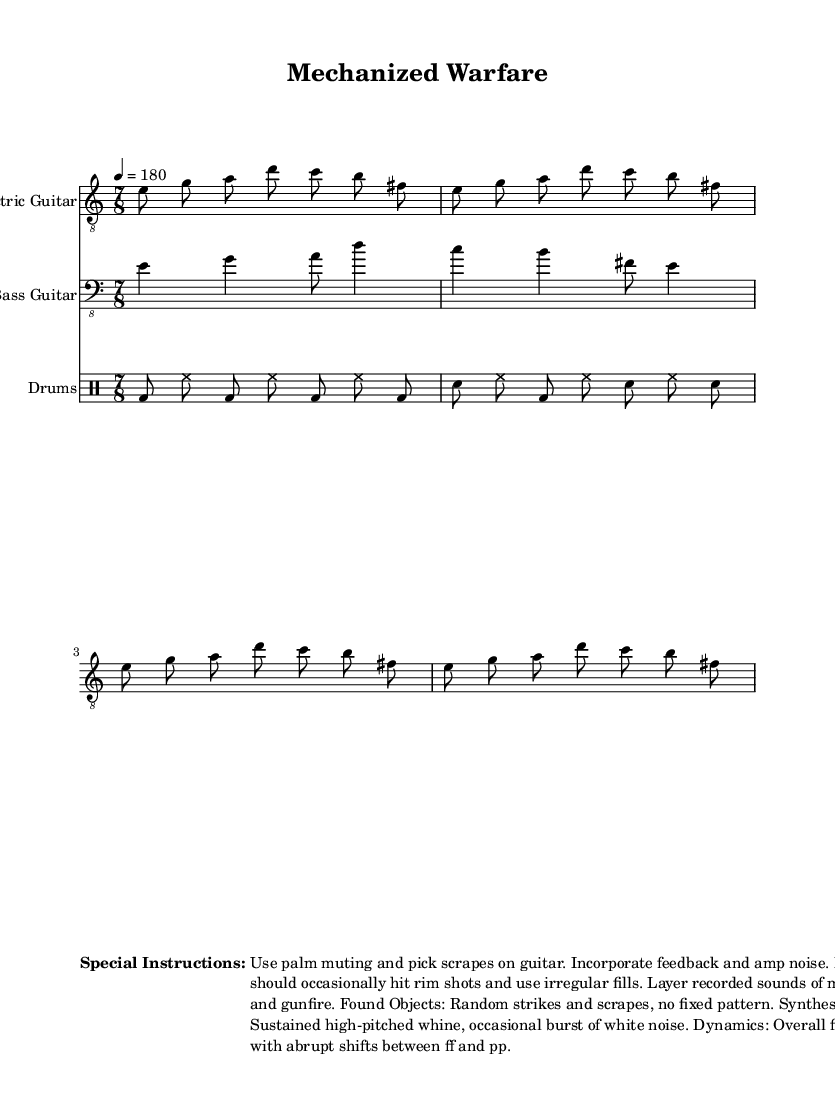what is the time signature of this music? The time signature is indicated at the beginning and shows that there are 7 beats per measure. This is represented as 7/8.
Answer: 7/8 what is the tempo marking of this piece? The tempo marking specifies that the quarter note equals 180 beats per minute, indicating a very fast pace.
Answer: 180 how many measures of music does the electric guitar section repeat? The electric guitar section has the repetition indicated by the "repeat unfold" instruction, which shows it repeats for 4 measures.
Answer: 4 what playing technique is specifically mentioned for the electric guitar? The instructions detail the use of palm muting and pick scrapes as key techniques for the performance of the electric guitar part.
Answer: palm muting and pick scrapes what is the overall dynamic level specified for this music? The overall dynamic marking indicates that the music should be played very loud (forte), with indications of abrupt dynamic shifts.
Answer: ff how should the drummers add variety to their playing? The instructions clarify that drummers should incorporate rim shots and irregular fills to create variety in their performance.
Answer: rim shots and irregular fills what type of sound should be layered into the music besides the instruments? The instructions specify that sounds of machinery and gunfire should be layered into the performance to enhance the theme of experimental noise punk.
Answer: sounds of machinery and gunfire 